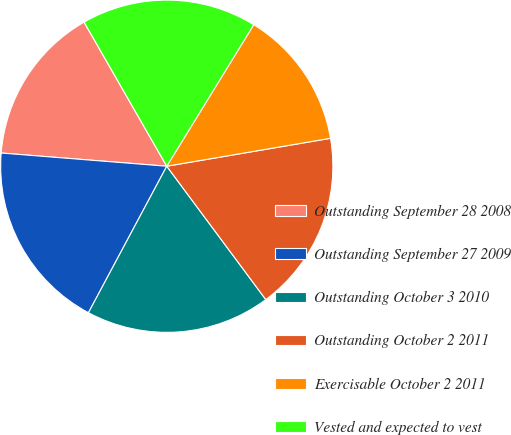Convert chart to OTSL. <chart><loc_0><loc_0><loc_500><loc_500><pie_chart><fcel>Outstanding September 28 2008<fcel>Outstanding September 27 2009<fcel>Outstanding October 3 2010<fcel>Outstanding October 2 2011<fcel>Exercisable October 2 2011<fcel>Vested and expected to vest<nl><fcel>15.44%<fcel>18.45%<fcel>17.98%<fcel>17.52%<fcel>13.54%<fcel>17.06%<nl></chart> 